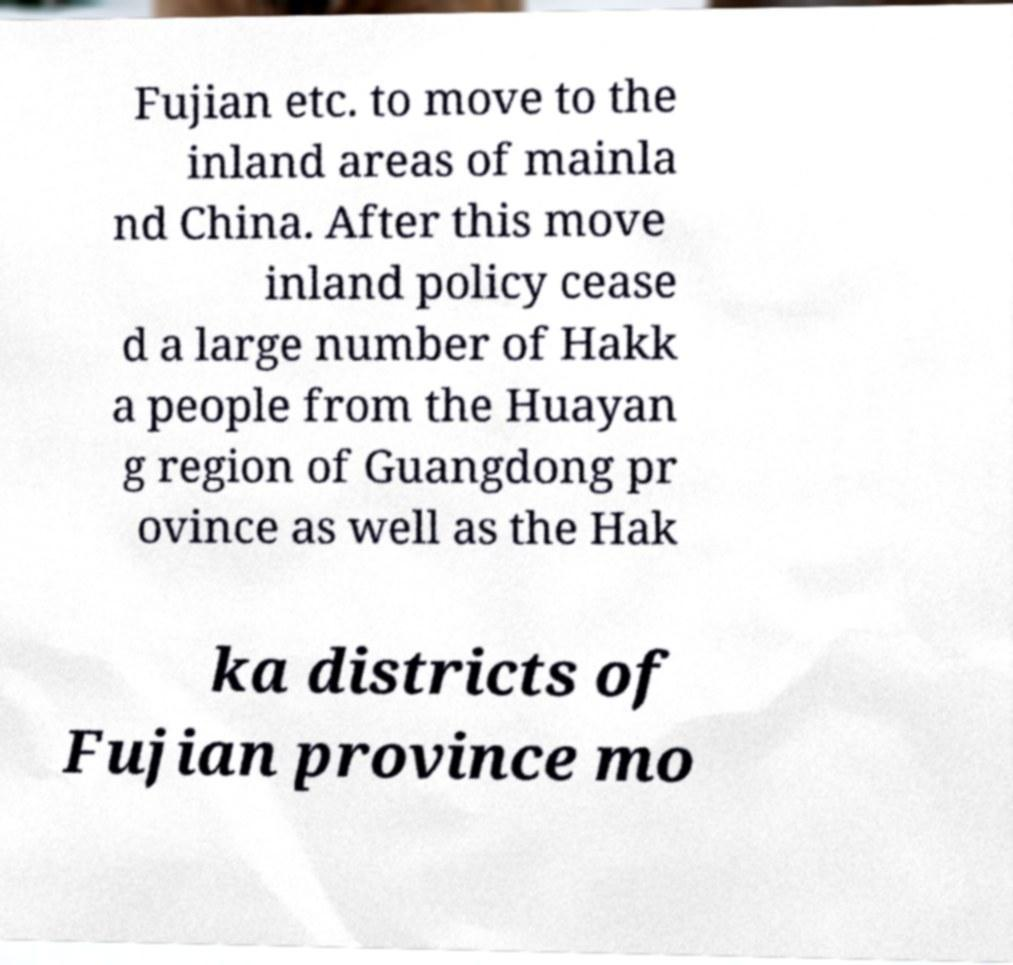Can you read and provide the text displayed in the image?This photo seems to have some interesting text. Can you extract and type it out for me? Fujian etc. to move to the inland areas of mainla nd China. After this move inland policy cease d a large number of Hakk a people from the Huayan g region of Guangdong pr ovince as well as the Hak ka districts of Fujian province mo 